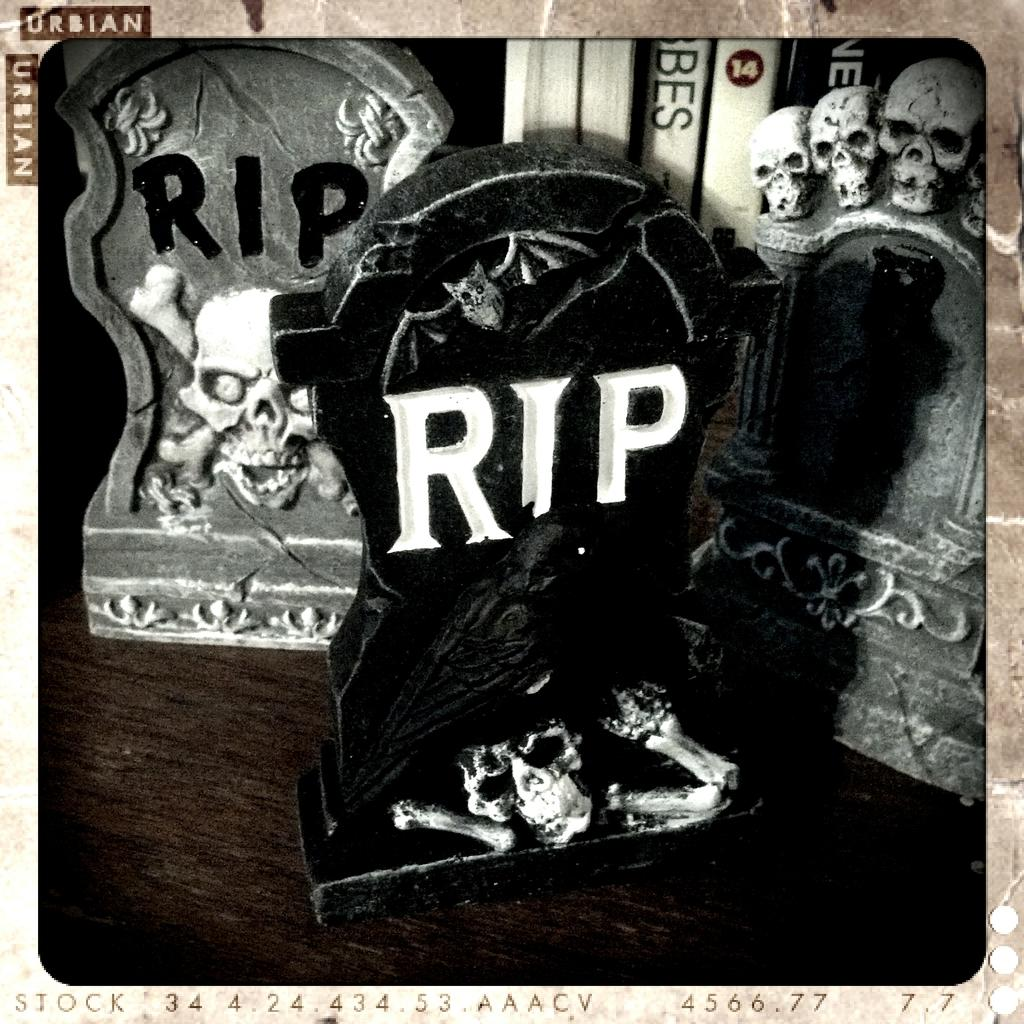Provide a one-sentence caption for the provided image. The small RIP headstones were on the table on display. 